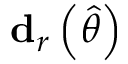<formula> <loc_0><loc_0><loc_500><loc_500>d _ { r } \left ( { \widehat { \theta } } \right )</formula> 